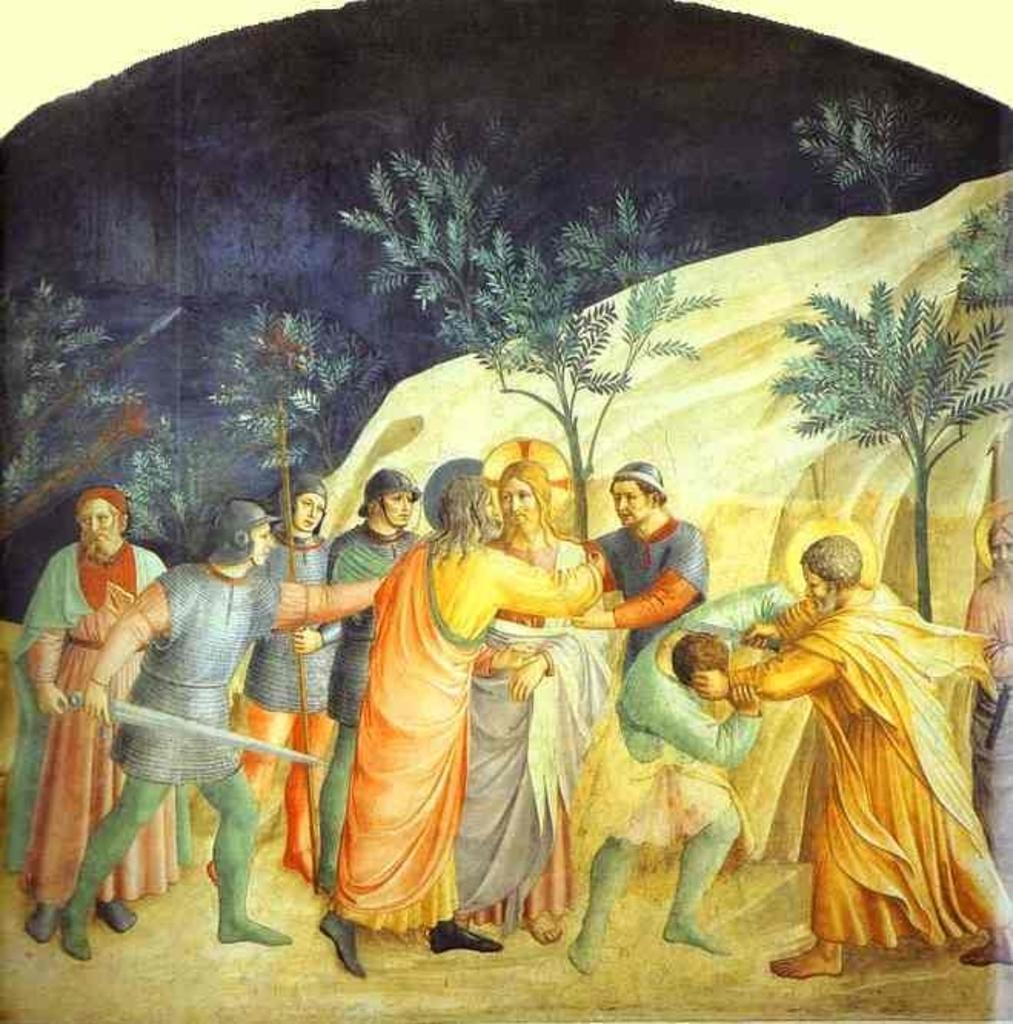What is the main subject of the image? The main subject of the image is a painting. What types of subjects are depicted in the painting? The painting contains persons and trees. Are there any other objects or elements in the painting? Yes, the painting contains other objects. What type of card is being used to water the plants in the painting? There is no card or hose present in the painting; it only contains persons, trees, and other objects. 